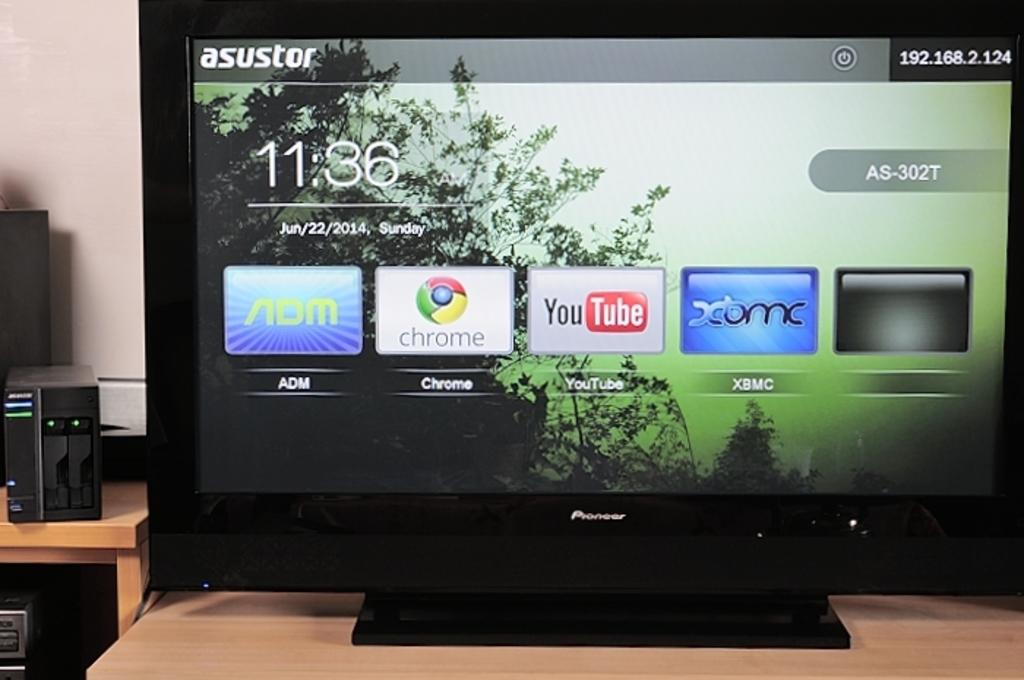Provide a one-sentence caption for the provided image. A smart TV screen shows icons for YouTube, Google Chrome, ADM and XMBC. 